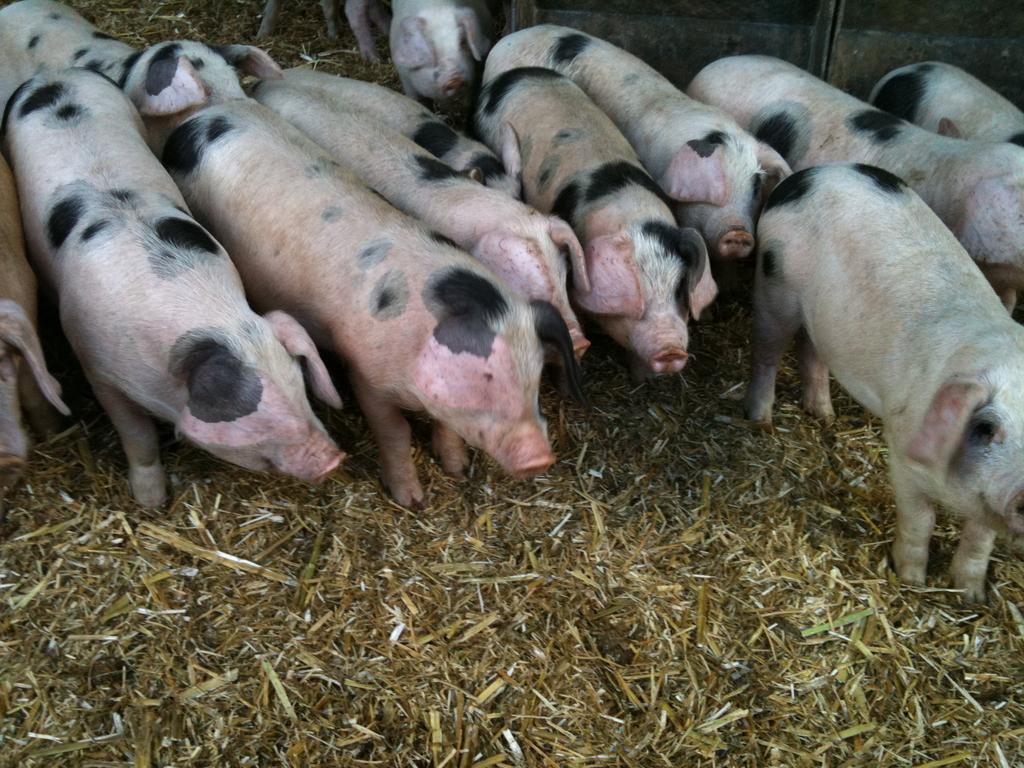Can you describe this image briefly? In this picture we can see some pigs are on the surface. 